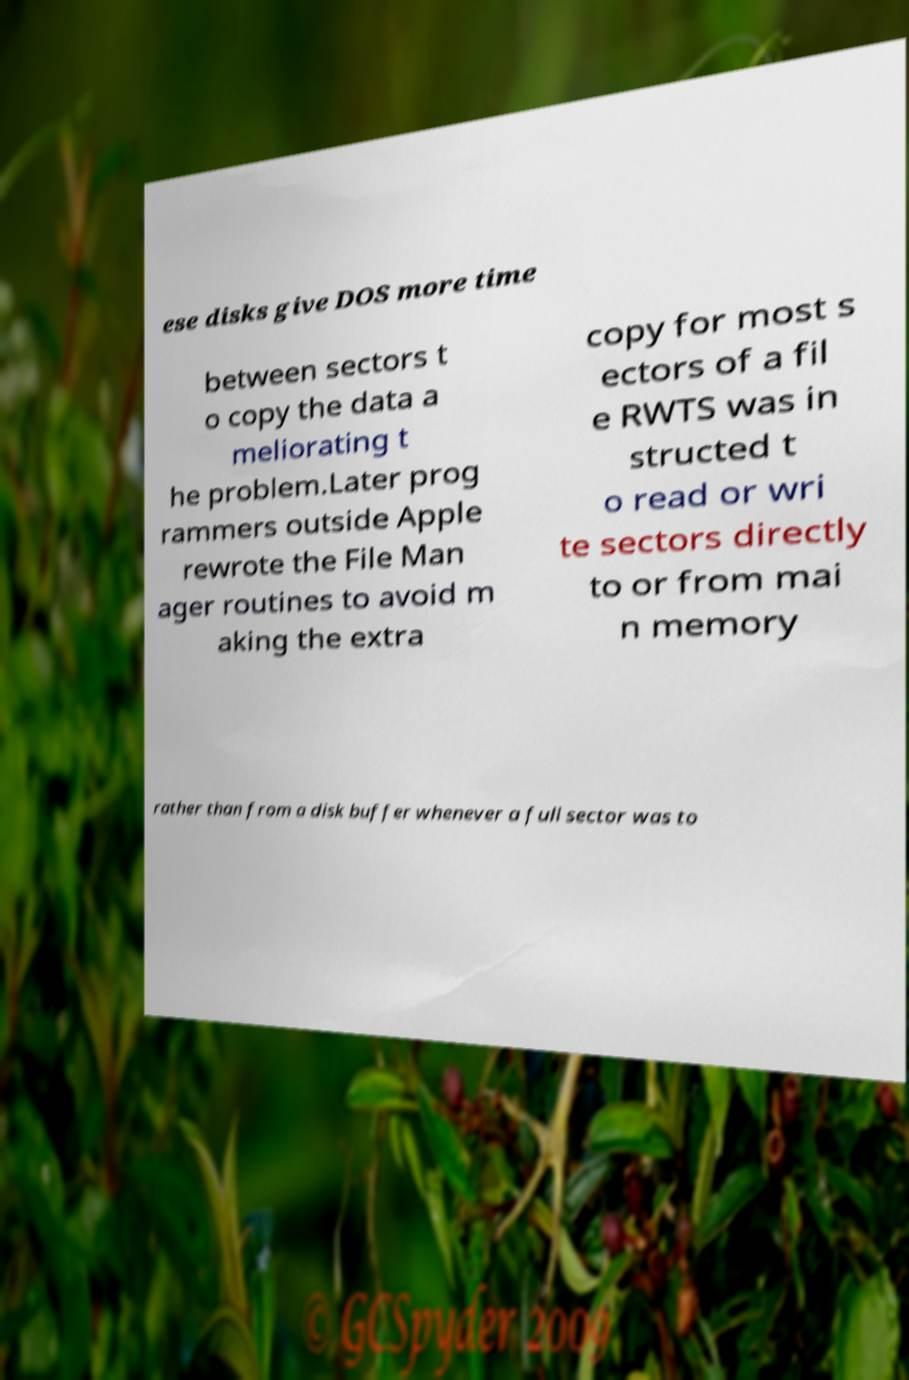For documentation purposes, I need the text within this image transcribed. Could you provide that? ese disks give DOS more time between sectors t o copy the data a meliorating t he problem.Later prog rammers outside Apple rewrote the File Man ager routines to avoid m aking the extra copy for most s ectors of a fil e RWTS was in structed t o read or wri te sectors directly to or from mai n memory rather than from a disk buffer whenever a full sector was to 